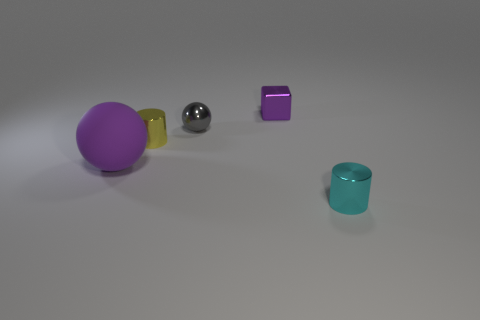What number of big things have the same material as the purple cube?
Make the answer very short. 0. What number of balls are on the right side of the purple ball to the left of the small yellow object?
Your answer should be compact. 1. There is a purple object behind the tiny cylinder behind the tiny metallic object in front of the rubber thing; what shape is it?
Make the answer very short. Cube. What is the size of the block that is the same color as the rubber sphere?
Your response must be concise. Small. What number of things are small blocks or small blue rubber cylinders?
Give a very brief answer. 1. There is a shiny cube that is the same size as the gray thing; what is its color?
Your answer should be very brief. Purple. Does the small gray object have the same shape as the purple object behind the small gray object?
Give a very brief answer. No. What number of objects are either big purple rubber spheres that are in front of the shiny block or spheres that are in front of the gray thing?
Your answer should be very brief. 1. What shape is the other object that is the same color as the big object?
Your response must be concise. Cube. The metal object behind the tiny gray shiny sphere has what shape?
Your response must be concise. Cube. 